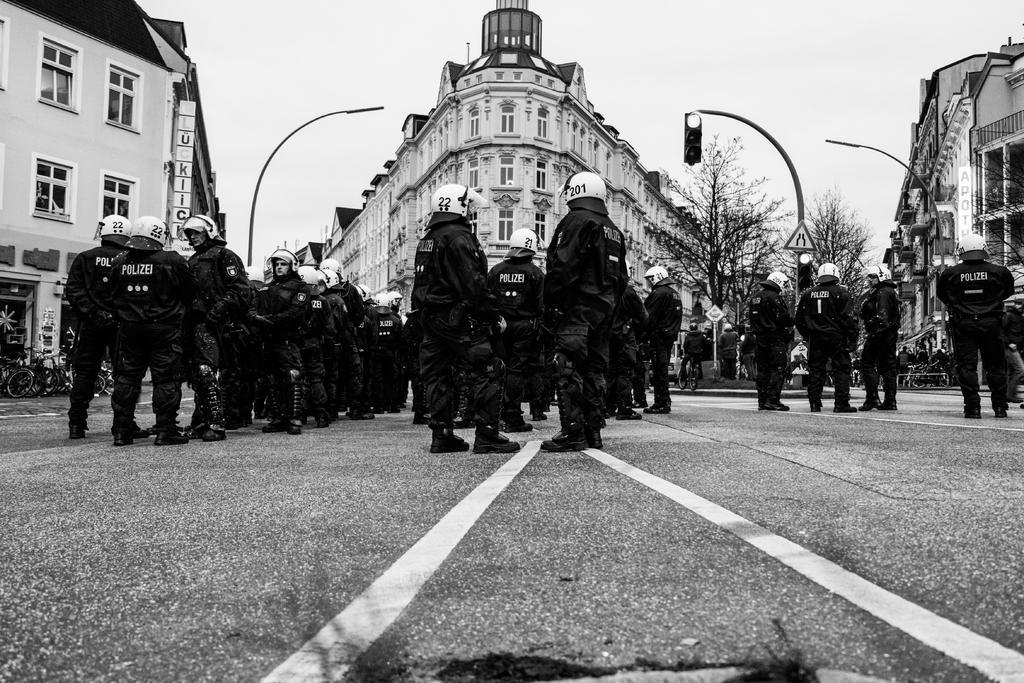Describe this image in one or two sentences. In this picture there are people standing on the road and wore helmets. We can see traffic signal, lights and board on poles. In the background of the image we can see buildings, trees, people, bicycles and sky. 